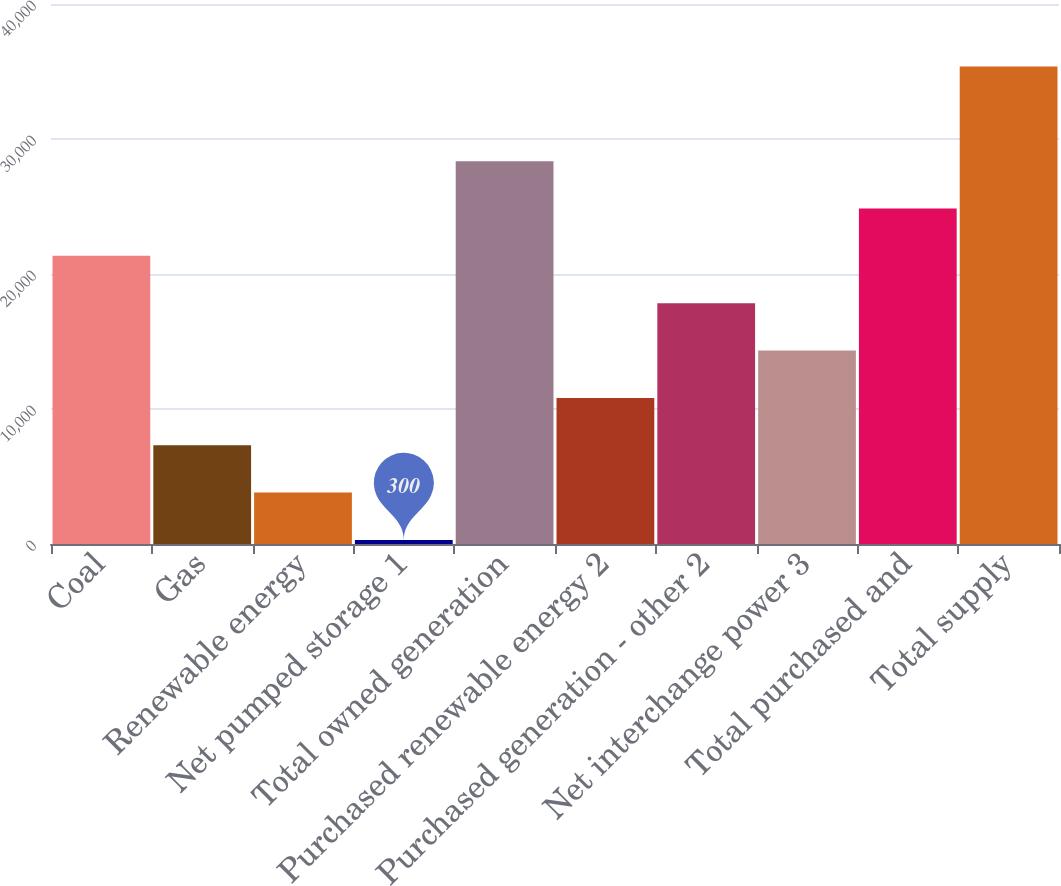Convert chart. <chart><loc_0><loc_0><loc_500><loc_500><bar_chart><fcel>Coal<fcel>Gas<fcel>Renewable energy<fcel>Net pumped storage 1<fcel>Total owned generation<fcel>Purchased renewable energy 2<fcel>Purchased generation - other 2<fcel>Net interchange power 3<fcel>Total purchased and<fcel>Total supply<nl><fcel>21345.6<fcel>7315.2<fcel>3807.6<fcel>300<fcel>28360.8<fcel>10822.8<fcel>17838<fcel>14330.4<fcel>24853.2<fcel>35376<nl></chart> 